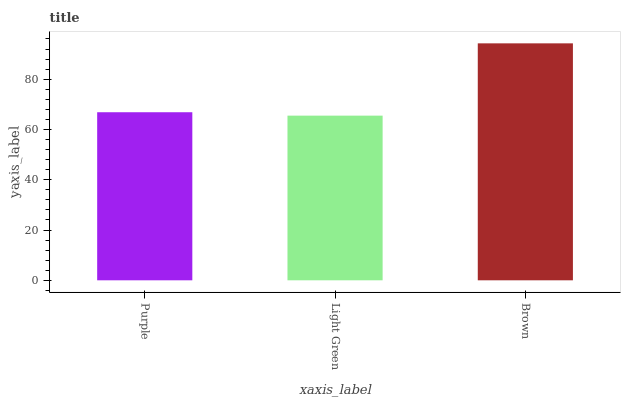Is Light Green the minimum?
Answer yes or no. Yes. Is Brown the maximum?
Answer yes or no. Yes. Is Brown the minimum?
Answer yes or no. No. Is Light Green the maximum?
Answer yes or no. No. Is Brown greater than Light Green?
Answer yes or no. Yes. Is Light Green less than Brown?
Answer yes or no. Yes. Is Light Green greater than Brown?
Answer yes or no. No. Is Brown less than Light Green?
Answer yes or no. No. Is Purple the high median?
Answer yes or no. Yes. Is Purple the low median?
Answer yes or no. Yes. Is Brown the high median?
Answer yes or no. No. Is Brown the low median?
Answer yes or no. No. 